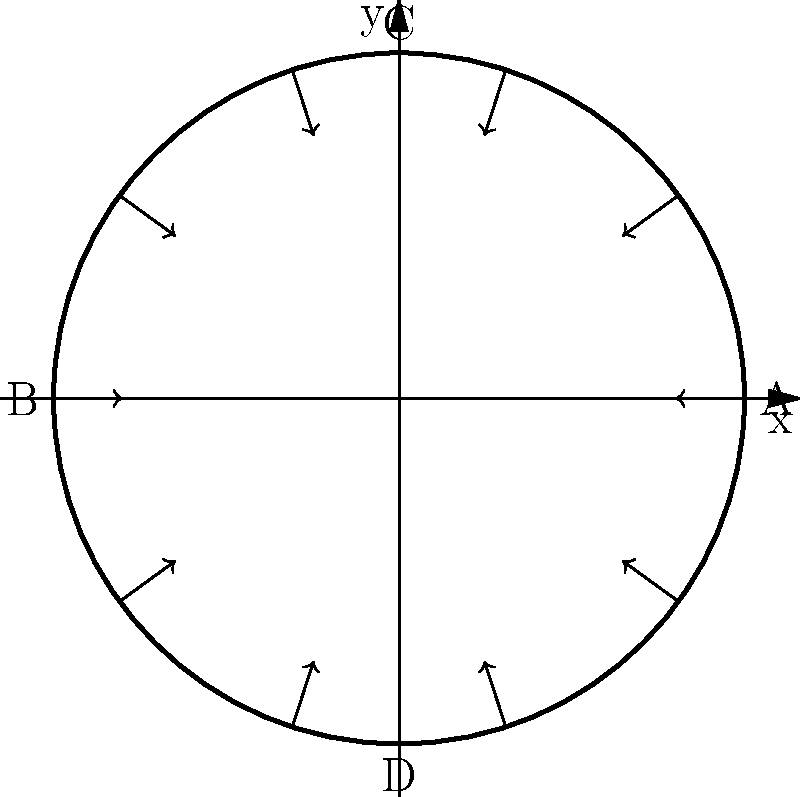In the cross-sectional diagram of a blood vessel shown above, which point experiences the highest pressure, and why? To determine the point of highest pressure in the blood vessel, we need to consider the principles of fluid dynamics and pressure distribution in circular vessels:

1. In a circular vessel, pressure is distributed radially due to the symmetry of the system.

2. The pressure at any point in the fluid is determined by the force exerted by the fluid column above it, known as hydrostatic pressure.

3. In a horizontal vessel, gravity acts perpendicular to the vessel's axis, creating a pressure gradient from top to bottom.

4. The pressure at the bottom of the vessel (point D) will be higher than at the top (point C) due to the weight of the fluid column.

5. Points A and B, being at the same vertical level, will experience equal pressures, intermediate between C and D.

6. The pressure difference between the top and bottom of the vessel is given by the equation:

   $$\Delta P = \rho g h$$

   where $\rho$ is the fluid density, $g$ is the acceleration due to gravity, and $h$ is the height difference (in this case, the diameter of the vessel).

7. Therefore, point D at the bottom of the vessel will experience the highest pressure.
Answer: Point D (bottom) 